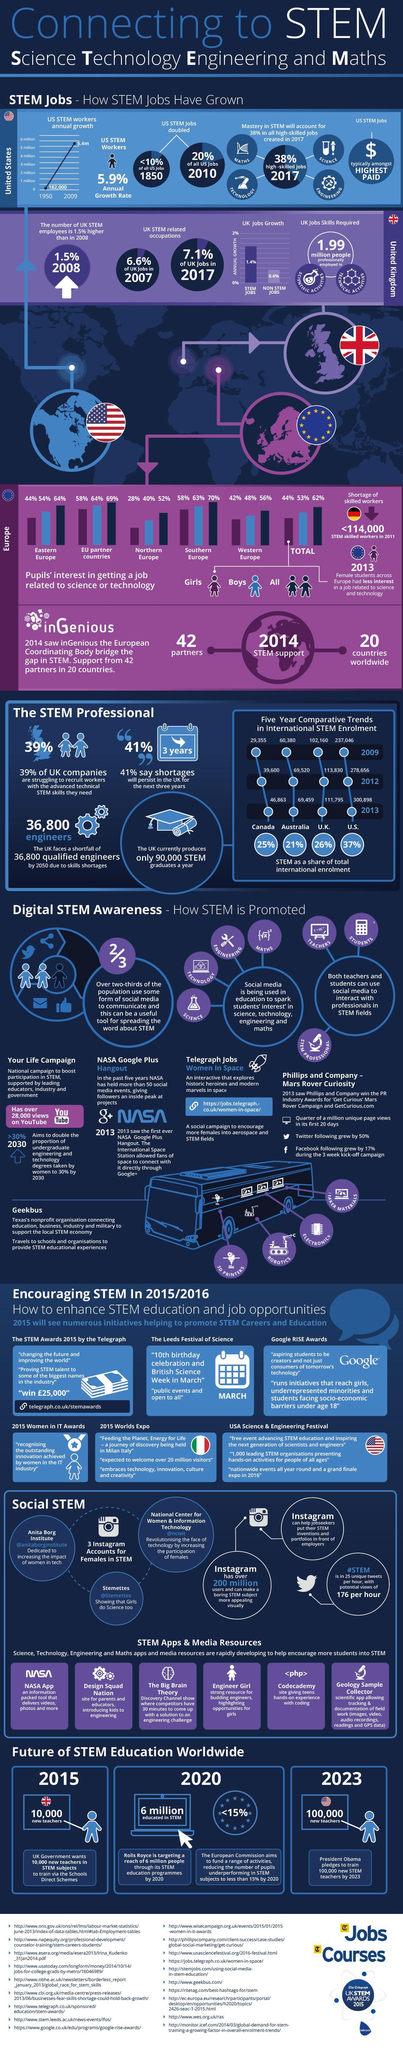Which is the highest paid job?
Answer the question with a short phrase. US STEM Jobs What is the percentage of girls and boys getting a job related to science or technology in Western Europe when taken together? 90% What is the percentage of girls and boys getting a job related to science or technology in Eastern Europe when taken together? 98% What is the percentage of stem jobs and non-stem jobs when taken together in the UK? 1.8% 